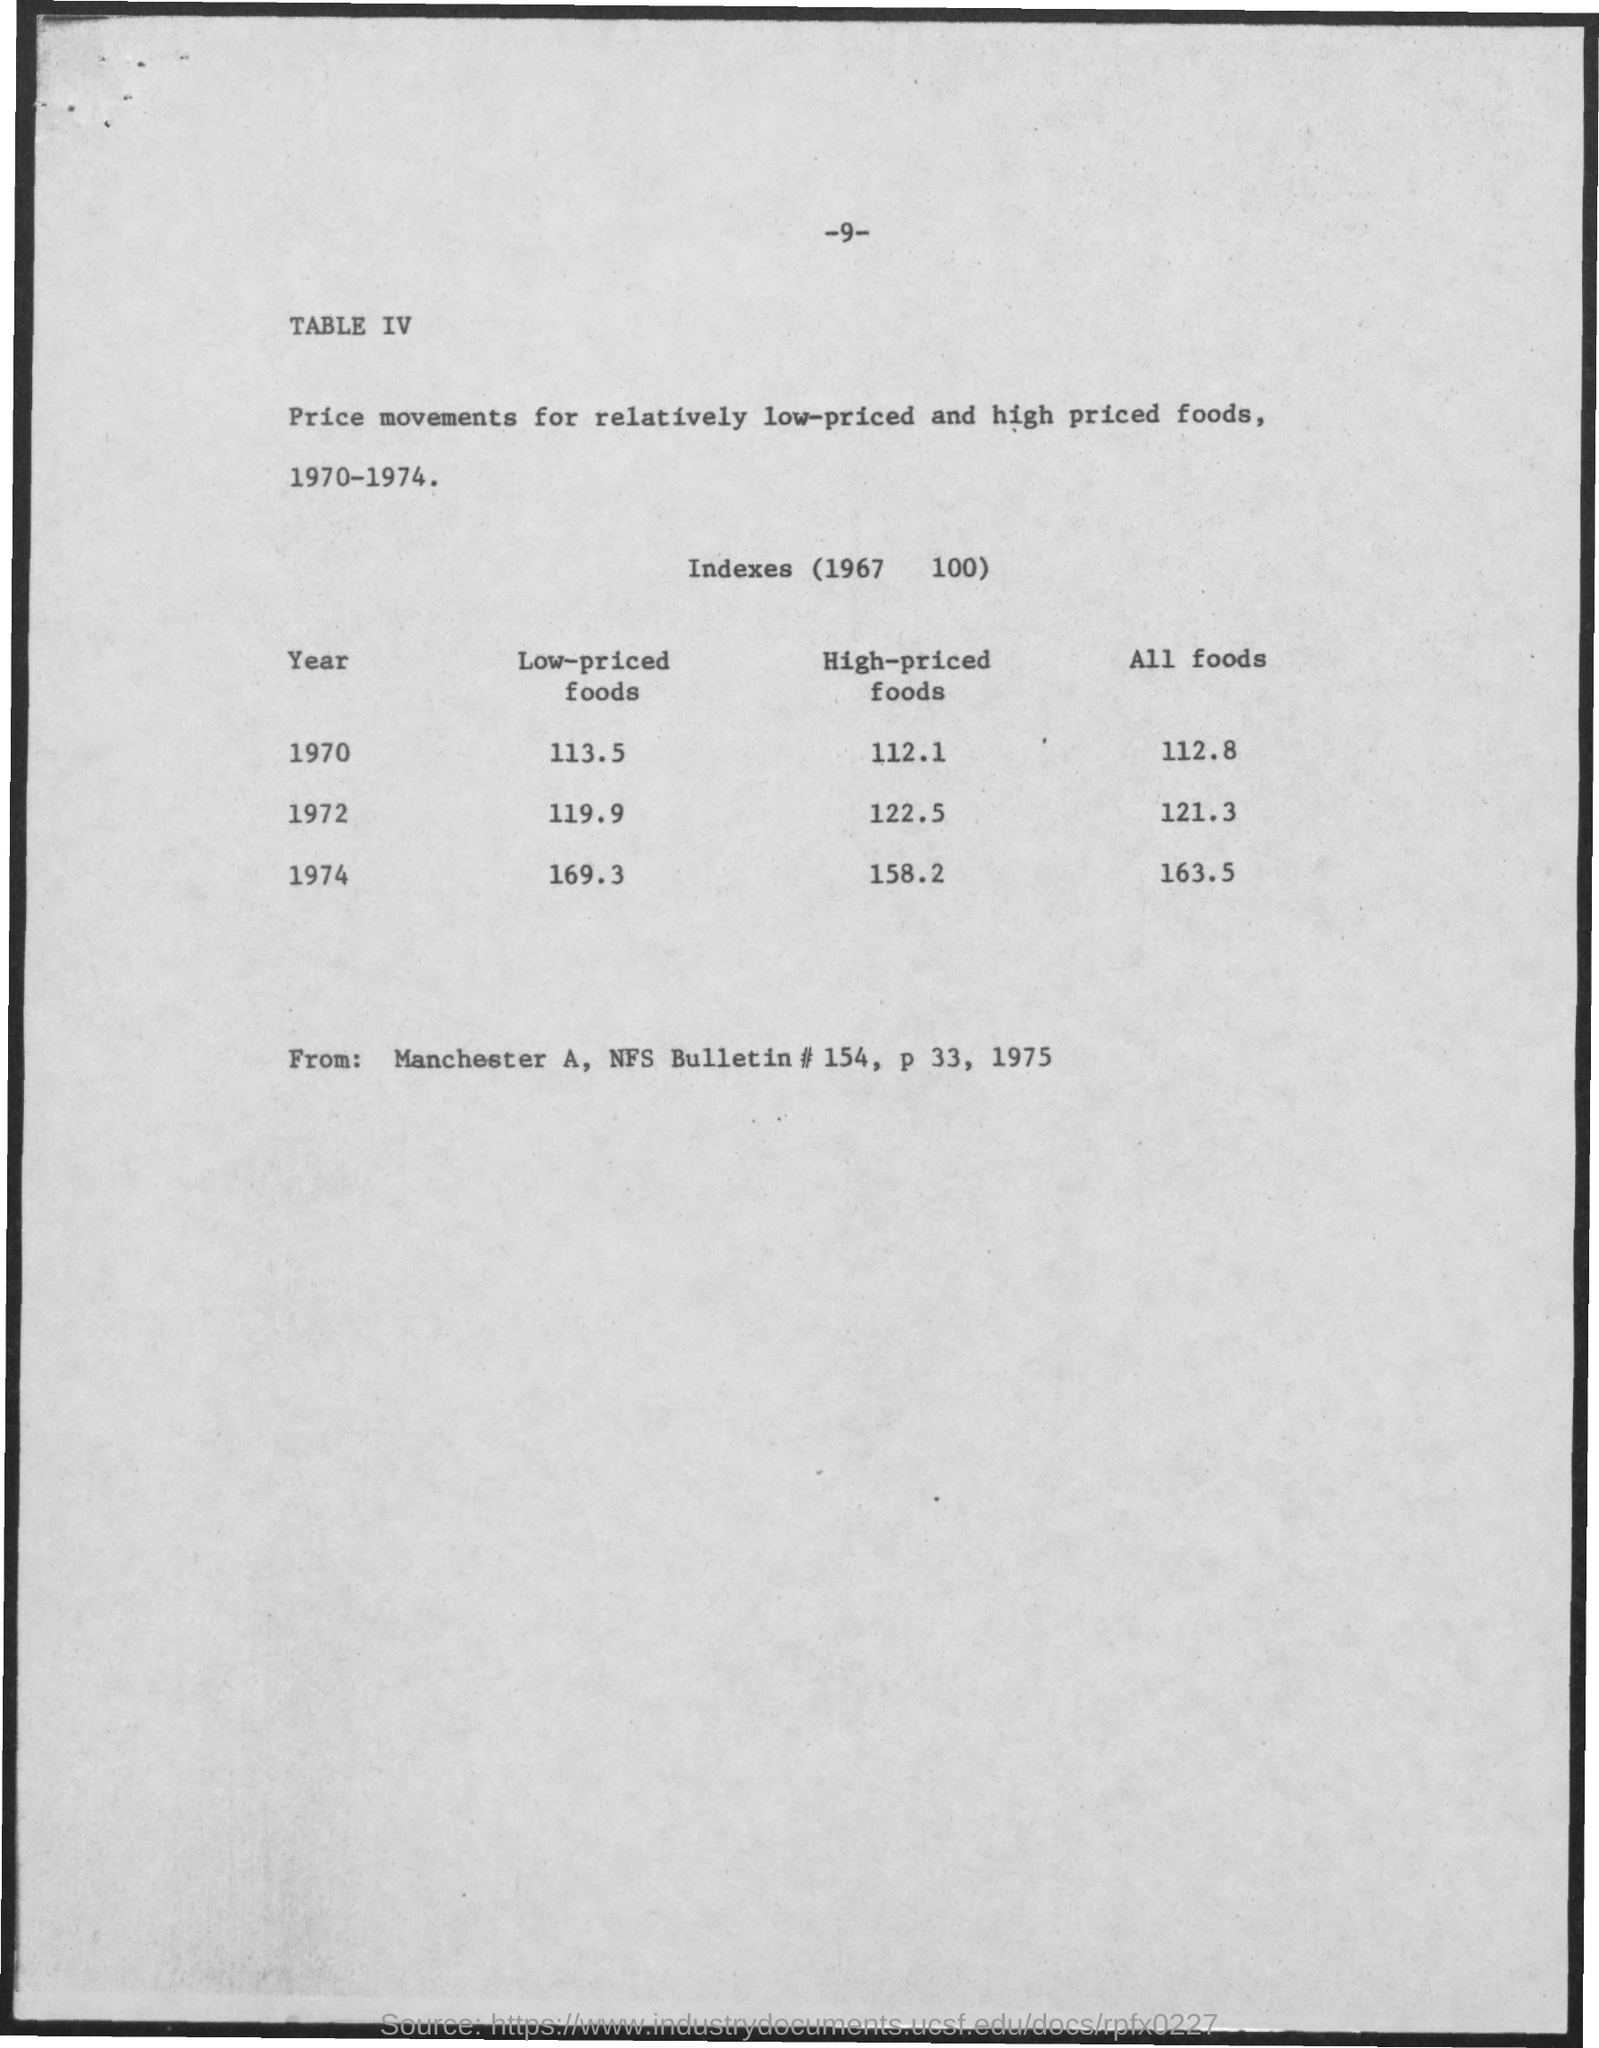Point out several critical features in this image. The Low-priced Foods Index for 1972 was 119.9. The "All foods" Index for 1972 was 121 with a coefficient of variation of 3%. The high-priced foods index for 1974 was 158.2. The high-priced foods index for 1970 was 112.1. The high-priced foods index for the year 1972 was 122.5. 